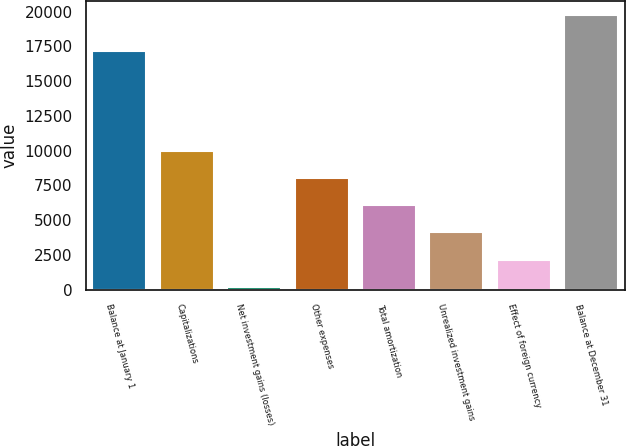<chart> <loc_0><loc_0><loc_500><loc_500><bar_chart><fcel>Balance at January 1<fcel>Capitalizations<fcel>Net investment gains (losses)<fcel>Other expenses<fcel>Total amortization<fcel>Unrealized investment gains<fcel>Effect of foreign currency<fcel>Balance at December 31<nl><fcel>17150<fcel>9983<fcel>192<fcel>8024.8<fcel>6066.6<fcel>4108.4<fcel>2150.2<fcel>19774<nl></chart> 